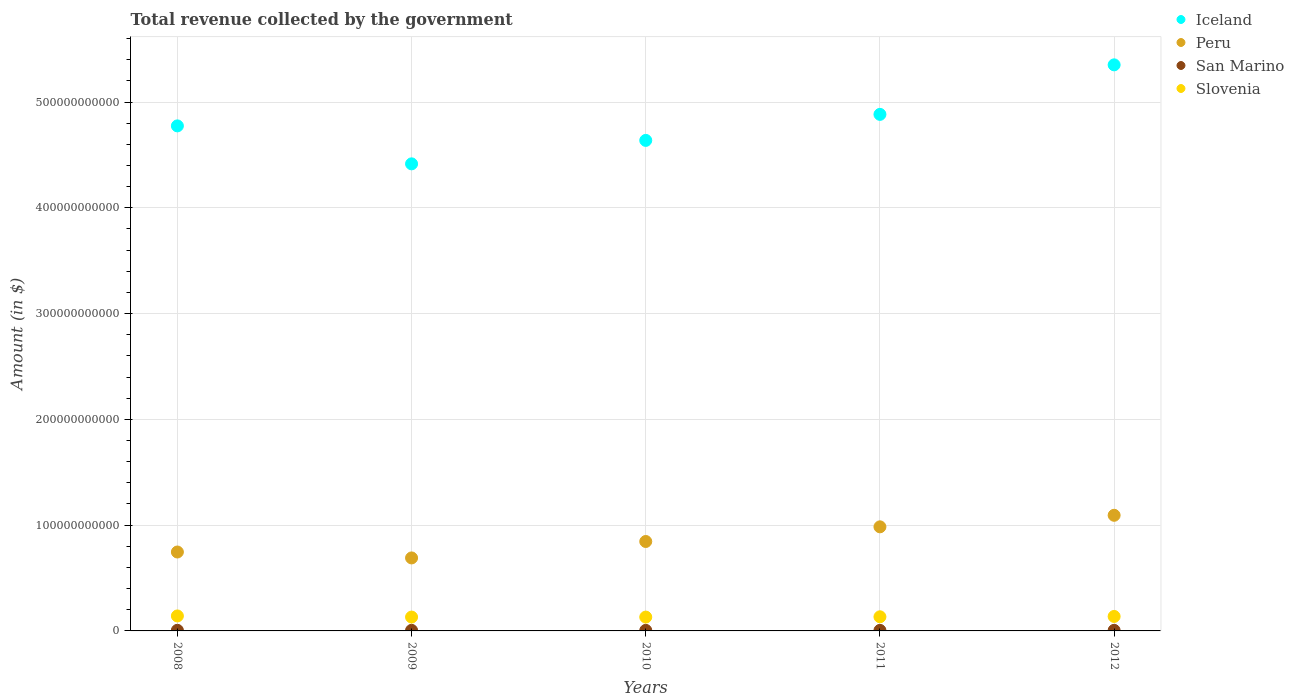How many different coloured dotlines are there?
Your response must be concise. 4. Is the number of dotlines equal to the number of legend labels?
Your answer should be compact. Yes. What is the total revenue collected by the government in San Marino in 2010?
Your answer should be compact. 5.31e+08. Across all years, what is the maximum total revenue collected by the government in Slovenia?
Keep it short and to the point. 1.42e+1. Across all years, what is the minimum total revenue collected by the government in Iceland?
Give a very brief answer. 4.42e+11. In which year was the total revenue collected by the government in Iceland maximum?
Give a very brief answer. 2012. In which year was the total revenue collected by the government in Peru minimum?
Your answer should be compact. 2009. What is the total total revenue collected by the government in Slovenia in the graph?
Give a very brief answer. 6.74e+1. What is the difference between the total revenue collected by the government in Peru in 2009 and that in 2012?
Your answer should be very brief. -4.03e+1. What is the difference between the total revenue collected by the government in Peru in 2011 and the total revenue collected by the government in Slovenia in 2008?
Your answer should be very brief. 8.42e+1. What is the average total revenue collected by the government in Slovenia per year?
Offer a very short reply. 1.35e+1. In the year 2011, what is the difference between the total revenue collected by the government in Slovenia and total revenue collected by the government in Iceland?
Give a very brief answer. -4.75e+11. What is the ratio of the total revenue collected by the government in Iceland in 2008 to that in 2009?
Your response must be concise. 1.08. Is the total revenue collected by the government in Peru in 2009 less than that in 2012?
Your answer should be compact. Yes. What is the difference between the highest and the second highest total revenue collected by the government in Iceland?
Ensure brevity in your answer.  4.68e+1. What is the difference between the highest and the lowest total revenue collected by the government in Iceland?
Keep it short and to the point. 9.36e+1. In how many years, is the total revenue collected by the government in Iceland greater than the average total revenue collected by the government in Iceland taken over all years?
Keep it short and to the point. 2. Is the sum of the total revenue collected by the government in Slovenia in 2009 and 2011 greater than the maximum total revenue collected by the government in Iceland across all years?
Keep it short and to the point. No. Does the total revenue collected by the government in Slovenia monotonically increase over the years?
Offer a terse response. No. Is the total revenue collected by the government in San Marino strictly greater than the total revenue collected by the government in Slovenia over the years?
Your response must be concise. No. How many years are there in the graph?
Your response must be concise. 5. What is the difference between two consecutive major ticks on the Y-axis?
Keep it short and to the point. 1.00e+11. Are the values on the major ticks of Y-axis written in scientific E-notation?
Offer a terse response. No. Does the graph contain any zero values?
Give a very brief answer. No. How many legend labels are there?
Offer a very short reply. 4. What is the title of the graph?
Provide a succinct answer. Total revenue collected by the government. What is the label or title of the Y-axis?
Offer a very short reply. Amount (in $). What is the Amount (in $) in Iceland in 2008?
Your answer should be very brief. 4.77e+11. What is the Amount (in $) in Peru in 2008?
Give a very brief answer. 7.46e+1. What is the Amount (in $) of San Marino in 2008?
Make the answer very short. 5.91e+08. What is the Amount (in $) in Slovenia in 2008?
Offer a very short reply. 1.42e+1. What is the Amount (in $) in Iceland in 2009?
Provide a short and direct response. 4.42e+11. What is the Amount (in $) of Peru in 2009?
Your answer should be very brief. 6.90e+1. What is the Amount (in $) in San Marino in 2009?
Your answer should be very brief. 5.62e+08. What is the Amount (in $) in Slovenia in 2009?
Your response must be concise. 1.31e+1. What is the Amount (in $) of Iceland in 2010?
Keep it short and to the point. 4.64e+11. What is the Amount (in $) in Peru in 2010?
Your answer should be compact. 8.45e+1. What is the Amount (in $) in San Marino in 2010?
Provide a short and direct response. 5.31e+08. What is the Amount (in $) in Slovenia in 2010?
Provide a succinct answer. 1.31e+1. What is the Amount (in $) in Iceland in 2011?
Your answer should be very brief. 4.88e+11. What is the Amount (in $) of Peru in 2011?
Offer a very short reply. 9.84e+1. What is the Amount (in $) in San Marino in 2011?
Your response must be concise. 5.23e+08. What is the Amount (in $) in Slovenia in 2011?
Provide a succinct answer. 1.34e+1. What is the Amount (in $) of Iceland in 2012?
Provide a succinct answer. 5.35e+11. What is the Amount (in $) in Peru in 2012?
Make the answer very short. 1.09e+11. What is the Amount (in $) of San Marino in 2012?
Ensure brevity in your answer.  5.53e+08. What is the Amount (in $) in Slovenia in 2012?
Offer a very short reply. 1.37e+1. Across all years, what is the maximum Amount (in $) of Iceland?
Your answer should be very brief. 5.35e+11. Across all years, what is the maximum Amount (in $) of Peru?
Provide a succinct answer. 1.09e+11. Across all years, what is the maximum Amount (in $) in San Marino?
Provide a succinct answer. 5.91e+08. Across all years, what is the maximum Amount (in $) in Slovenia?
Make the answer very short. 1.42e+1. Across all years, what is the minimum Amount (in $) in Iceland?
Offer a terse response. 4.42e+11. Across all years, what is the minimum Amount (in $) of Peru?
Provide a succinct answer. 6.90e+1. Across all years, what is the minimum Amount (in $) of San Marino?
Make the answer very short. 5.23e+08. Across all years, what is the minimum Amount (in $) in Slovenia?
Provide a succinct answer. 1.31e+1. What is the total Amount (in $) of Iceland in the graph?
Give a very brief answer. 2.41e+12. What is the total Amount (in $) in Peru in the graph?
Your response must be concise. 4.36e+11. What is the total Amount (in $) of San Marino in the graph?
Your answer should be very brief. 2.76e+09. What is the total Amount (in $) in Slovenia in the graph?
Make the answer very short. 6.74e+1. What is the difference between the Amount (in $) of Iceland in 2008 and that in 2009?
Provide a succinct answer. 3.59e+1. What is the difference between the Amount (in $) of Peru in 2008 and that in 2009?
Provide a short and direct response. 5.60e+09. What is the difference between the Amount (in $) in San Marino in 2008 and that in 2009?
Provide a succinct answer. 2.87e+07. What is the difference between the Amount (in $) in Slovenia in 2008 and that in 2009?
Provide a short and direct response. 1.07e+09. What is the difference between the Amount (in $) of Iceland in 2008 and that in 2010?
Your answer should be very brief. 1.37e+1. What is the difference between the Amount (in $) of Peru in 2008 and that in 2010?
Your answer should be very brief. -9.94e+09. What is the difference between the Amount (in $) in San Marino in 2008 and that in 2010?
Your answer should be compact. 6.02e+07. What is the difference between the Amount (in $) of Slovenia in 2008 and that in 2010?
Keep it short and to the point. 1.08e+09. What is the difference between the Amount (in $) in Iceland in 2008 and that in 2011?
Your response must be concise. -1.09e+1. What is the difference between the Amount (in $) of Peru in 2008 and that in 2011?
Your response must be concise. -2.38e+1. What is the difference between the Amount (in $) of San Marino in 2008 and that in 2011?
Give a very brief answer. 6.76e+07. What is the difference between the Amount (in $) of Slovenia in 2008 and that in 2011?
Provide a succinct answer. 8.01e+08. What is the difference between the Amount (in $) of Iceland in 2008 and that in 2012?
Your response must be concise. -5.77e+1. What is the difference between the Amount (in $) in Peru in 2008 and that in 2012?
Your response must be concise. -3.47e+1. What is the difference between the Amount (in $) of San Marino in 2008 and that in 2012?
Your response must be concise. 3.76e+07. What is the difference between the Amount (in $) of Slovenia in 2008 and that in 2012?
Provide a succinct answer. 4.74e+08. What is the difference between the Amount (in $) in Iceland in 2009 and that in 2010?
Make the answer very short. -2.22e+1. What is the difference between the Amount (in $) of Peru in 2009 and that in 2010?
Give a very brief answer. -1.55e+1. What is the difference between the Amount (in $) of San Marino in 2009 and that in 2010?
Give a very brief answer. 3.15e+07. What is the difference between the Amount (in $) in Slovenia in 2009 and that in 2010?
Provide a succinct answer. 1.26e+07. What is the difference between the Amount (in $) of Iceland in 2009 and that in 2011?
Make the answer very short. -4.68e+1. What is the difference between the Amount (in $) of Peru in 2009 and that in 2011?
Your answer should be compact. -2.94e+1. What is the difference between the Amount (in $) of San Marino in 2009 and that in 2011?
Your answer should be compact. 3.89e+07. What is the difference between the Amount (in $) in Slovenia in 2009 and that in 2011?
Provide a succinct answer. -2.66e+08. What is the difference between the Amount (in $) in Iceland in 2009 and that in 2012?
Offer a terse response. -9.36e+1. What is the difference between the Amount (in $) of Peru in 2009 and that in 2012?
Offer a terse response. -4.03e+1. What is the difference between the Amount (in $) of San Marino in 2009 and that in 2012?
Provide a succinct answer. 8.90e+06. What is the difference between the Amount (in $) in Slovenia in 2009 and that in 2012?
Your answer should be very brief. -5.93e+08. What is the difference between the Amount (in $) in Iceland in 2010 and that in 2011?
Offer a terse response. -2.46e+1. What is the difference between the Amount (in $) of Peru in 2010 and that in 2011?
Provide a succinct answer. -1.39e+1. What is the difference between the Amount (in $) in San Marino in 2010 and that in 2011?
Ensure brevity in your answer.  7.36e+06. What is the difference between the Amount (in $) of Slovenia in 2010 and that in 2011?
Offer a terse response. -2.78e+08. What is the difference between the Amount (in $) of Iceland in 2010 and that in 2012?
Ensure brevity in your answer.  -7.14e+1. What is the difference between the Amount (in $) of Peru in 2010 and that in 2012?
Your response must be concise. -2.48e+1. What is the difference between the Amount (in $) in San Marino in 2010 and that in 2012?
Your response must be concise. -2.26e+07. What is the difference between the Amount (in $) in Slovenia in 2010 and that in 2012?
Offer a very short reply. -6.06e+08. What is the difference between the Amount (in $) in Iceland in 2011 and that in 2012?
Keep it short and to the point. -4.68e+1. What is the difference between the Amount (in $) of Peru in 2011 and that in 2012?
Your answer should be compact. -1.09e+1. What is the difference between the Amount (in $) in San Marino in 2011 and that in 2012?
Your response must be concise. -3.00e+07. What is the difference between the Amount (in $) of Slovenia in 2011 and that in 2012?
Your answer should be compact. -3.27e+08. What is the difference between the Amount (in $) of Iceland in 2008 and the Amount (in $) of Peru in 2009?
Your answer should be compact. 4.08e+11. What is the difference between the Amount (in $) in Iceland in 2008 and the Amount (in $) in San Marino in 2009?
Give a very brief answer. 4.77e+11. What is the difference between the Amount (in $) in Iceland in 2008 and the Amount (in $) in Slovenia in 2009?
Provide a succinct answer. 4.64e+11. What is the difference between the Amount (in $) of Peru in 2008 and the Amount (in $) of San Marino in 2009?
Your answer should be compact. 7.40e+1. What is the difference between the Amount (in $) in Peru in 2008 and the Amount (in $) in Slovenia in 2009?
Offer a very short reply. 6.15e+1. What is the difference between the Amount (in $) of San Marino in 2008 and the Amount (in $) of Slovenia in 2009?
Give a very brief answer. -1.25e+1. What is the difference between the Amount (in $) of Iceland in 2008 and the Amount (in $) of Peru in 2010?
Give a very brief answer. 3.93e+11. What is the difference between the Amount (in $) of Iceland in 2008 and the Amount (in $) of San Marino in 2010?
Give a very brief answer. 4.77e+11. What is the difference between the Amount (in $) of Iceland in 2008 and the Amount (in $) of Slovenia in 2010?
Ensure brevity in your answer.  4.64e+11. What is the difference between the Amount (in $) in Peru in 2008 and the Amount (in $) in San Marino in 2010?
Provide a succinct answer. 7.41e+1. What is the difference between the Amount (in $) in Peru in 2008 and the Amount (in $) in Slovenia in 2010?
Give a very brief answer. 6.15e+1. What is the difference between the Amount (in $) of San Marino in 2008 and the Amount (in $) of Slovenia in 2010?
Offer a terse response. -1.25e+1. What is the difference between the Amount (in $) of Iceland in 2008 and the Amount (in $) of Peru in 2011?
Keep it short and to the point. 3.79e+11. What is the difference between the Amount (in $) in Iceland in 2008 and the Amount (in $) in San Marino in 2011?
Ensure brevity in your answer.  4.77e+11. What is the difference between the Amount (in $) in Iceland in 2008 and the Amount (in $) in Slovenia in 2011?
Give a very brief answer. 4.64e+11. What is the difference between the Amount (in $) in Peru in 2008 and the Amount (in $) in San Marino in 2011?
Offer a terse response. 7.41e+1. What is the difference between the Amount (in $) of Peru in 2008 and the Amount (in $) of Slovenia in 2011?
Your answer should be compact. 6.12e+1. What is the difference between the Amount (in $) in San Marino in 2008 and the Amount (in $) in Slovenia in 2011?
Your answer should be compact. -1.28e+1. What is the difference between the Amount (in $) of Iceland in 2008 and the Amount (in $) of Peru in 2012?
Keep it short and to the point. 3.68e+11. What is the difference between the Amount (in $) of Iceland in 2008 and the Amount (in $) of San Marino in 2012?
Your response must be concise. 4.77e+11. What is the difference between the Amount (in $) in Iceland in 2008 and the Amount (in $) in Slovenia in 2012?
Make the answer very short. 4.64e+11. What is the difference between the Amount (in $) of Peru in 2008 and the Amount (in $) of San Marino in 2012?
Your response must be concise. 7.41e+1. What is the difference between the Amount (in $) of Peru in 2008 and the Amount (in $) of Slovenia in 2012?
Provide a succinct answer. 6.09e+1. What is the difference between the Amount (in $) in San Marino in 2008 and the Amount (in $) in Slovenia in 2012?
Ensure brevity in your answer.  -1.31e+1. What is the difference between the Amount (in $) in Iceland in 2009 and the Amount (in $) in Peru in 2010?
Provide a short and direct response. 3.57e+11. What is the difference between the Amount (in $) of Iceland in 2009 and the Amount (in $) of San Marino in 2010?
Give a very brief answer. 4.41e+11. What is the difference between the Amount (in $) of Iceland in 2009 and the Amount (in $) of Slovenia in 2010?
Provide a short and direct response. 4.28e+11. What is the difference between the Amount (in $) in Peru in 2009 and the Amount (in $) in San Marino in 2010?
Provide a short and direct response. 6.85e+1. What is the difference between the Amount (in $) in Peru in 2009 and the Amount (in $) in Slovenia in 2010?
Make the answer very short. 5.59e+1. What is the difference between the Amount (in $) in San Marino in 2009 and the Amount (in $) in Slovenia in 2010?
Your response must be concise. -1.25e+1. What is the difference between the Amount (in $) of Iceland in 2009 and the Amount (in $) of Peru in 2011?
Make the answer very short. 3.43e+11. What is the difference between the Amount (in $) of Iceland in 2009 and the Amount (in $) of San Marino in 2011?
Your answer should be very brief. 4.41e+11. What is the difference between the Amount (in $) in Iceland in 2009 and the Amount (in $) in Slovenia in 2011?
Ensure brevity in your answer.  4.28e+11. What is the difference between the Amount (in $) in Peru in 2009 and the Amount (in $) in San Marino in 2011?
Your answer should be compact. 6.85e+1. What is the difference between the Amount (in $) of Peru in 2009 and the Amount (in $) of Slovenia in 2011?
Provide a short and direct response. 5.57e+1. What is the difference between the Amount (in $) of San Marino in 2009 and the Amount (in $) of Slovenia in 2011?
Your answer should be very brief. -1.28e+1. What is the difference between the Amount (in $) of Iceland in 2009 and the Amount (in $) of Peru in 2012?
Your response must be concise. 3.32e+11. What is the difference between the Amount (in $) of Iceland in 2009 and the Amount (in $) of San Marino in 2012?
Give a very brief answer. 4.41e+11. What is the difference between the Amount (in $) of Iceland in 2009 and the Amount (in $) of Slovenia in 2012?
Provide a succinct answer. 4.28e+11. What is the difference between the Amount (in $) of Peru in 2009 and the Amount (in $) of San Marino in 2012?
Your answer should be very brief. 6.85e+1. What is the difference between the Amount (in $) in Peru in 2009 and the Amount (in $) in Slovenia in 2012?
Make the answer very short. 5.53e+1. What is the difference between the Amount (in $) of San Marino in 2009 and the Amount (in $) of Slovenia in 2012?
Your answer should be compact. -1.31e+1. What is the difference between the Amount (in $) in Iceland in 2010 and the Amount (in $) in Peru in 2011?
Keep it short and to the point. 3.65e+11. What is the difference between the Amount (in $) in Iceland in 2010 and the Amount (in $) in San Marino in 2011?
Ensure brevity in your answer.  4.63e+11. What is the difference between the Amount (in $) of Iceland in 2010 and the Amount (in $) of Slovenia in 2011?
Offer a very short reply. 4.50e+11. What is the difference between the Amount (in $) in Peru in 2010 and the Amount (in $) in San Marino in 2011?
Keep it short and to the point. 8.40e+1. What is the difference between the Amount (in $) in Peru in 2010 and the Amount (in $) in Slovenia in 2011?
Ensure brevity in your answer.  7.12e+1. What is the difference between the Amount (in $) of San Marino in 2010 and the Amount (in $) of Slovenia in 2011?
Offer a very short reply. -1.28e+1. What is the difference between the Amount (in $) of Iceland in 2010 and the Amount (in $) of Peru in 2012?
Provide a short and direct response. 3.54e+11. What is the difference between the Amount (in $) of Iceland in 2010 and the Amount (in $) of San Marino in 2012?
Offer a terse response. 4.63e+11. What is the difference between the Amount (in $) in Iceland in 2010 and the Amount (in $) in Slovenia in 2012?
Provide a succinct answer. 4.50e+11. What is the difference between the Amount (in $) of Peru in 2010 and the Amount (in $) of San Marino in 2012?
Offer a very short reply. 8.40e+1. What is the difference between the Amount (in $) of Peru in 2010 and the Amount (in $) of Slovenia in 2012?
Offer a very short reply. 7.09e+1. What is the difference between the Amount (in $) of San Marino in 2010 and the Amount (in $) of Slovenia in 2012?
Keep it short and to the point. -1.32e+1. What is the difference between the Amount (in $) in Iceland in 2011 and the Amount (in $) in Peru in 2012?
Ensure brevity in your answer.  3.79e+11. What is the difference between the Amount (in $) in Iceland in 2011 and the Amount (in $) in San Marino in 2012?
Your answer should be compact. 4.88e+11. What is the difference between the Amount (in $) in Iceland in 2011 and the Amount (in $) in Slovenia in 2012?
Keep it short and to the point. 4.75e+11. What is the difference between the Amount (in $) in Peru in 2011 and the Amount (in $) in San Marino in 2012?
Make the answer very short. 9.79e+1. What is the difference between the Amount (in $) in Peru in 2011 and the Amount (in $) in Slovenia in 2012?
Give a very brief answer. 8.47e+1. What is the difference between the Amount (in $) in San Marino in 2011 and the Amount (in $) in Slovenia in 2012?
Provide a succinct answer. -1.32e+1. What is the average Amount (in $) in Iceland per year?
Offer a very short reply. 4.81e+11. What is the average Amount (in $) in Peru per year?
Offer a terse response. 8.72e+1. What is the average Amount (in $) in San Marino per year?
Provide a short and direct response. 5.52e+08. What is the average Amount (in $) in Slovenia per year?
Provide a short and direct response. 1.35e+1. In the year 2008, what is the difference between the Amount (in $) in Iceland and Amount (in $) in Peru?
Your response must be concise. 4.03e+11. In the year 2008, what is the difference between the Amount (in $) in Iceland and Amount (in $) in San Marino?
Your response must be concise. 4.77e+11. In the year 2008, what is the difference between the Amount (in $) in Iceland and Amount (in $) in Slovenia?
Your answer should be very brief. 4.63e+11. In the year 2008, what is the difference between the Amount (in $) of Peru and Amount (in $) of San Marino?
Give a very brief answer. 7.40e+1. In the year 2008, what is the difference between the Amount (in $) in Peru and Amount (in $) in Slovenia?
Give a very brief answer. 6.04e+1. In the year 2008, what is the difference between the Amount (in $) in San Marino and Amount (in $) in Slovenia?
Make the answer very short. -1.36e+1. In the year 2009, what is the difference between the Amount (in $) of Iceland and Amount (in $) of Peru?
Offer a terse response. 3.73e+11. In the year 2009, what is the difference between the Amount (in $) in Iceland and Amount (in $) in San Marino?
Make the answer very short. 4.41e+11. In the year 2009, what is the difference between the Amount (in $) of Iceland and Amount (in $) of Slovenia?
Offer a very short reply. 4.28e+11. In the year 2009, what is the difference between the Amount (in $) in Peru and Amount (in $) in San Marino?
Provide a short and direct response. 6.84e+1. In the year 2009, what is the difference between the Amount (in $) of Peru and Amount (in $) of Slovenia?
Provide a short and direct response. 5.59e+1. In the year 2009, what is the difference between the Amount (in $) in San Marino and Amount (in $) in Slovenia?
Offer a terse response. -1.25e+1. In the year 2010, what is the difference between the Amount (in $) in Iceland and Amount (in $) in Peru?
Keep it short and to the point. 3.79e+11. In the year 2010, what is the difference between the Amount (in $) in Iceland and Amount (in $) in San Marino?
Your response must be concise. 4.63e+11. In the year 2010, what is the difference between the Amount (in $) of Iceland and Amount (in $) of Slovenia?
Provide a succinct answer. 4.51e+11. In the year 2010, what is the difference between the Amount (in $) in Peru and Amount (in $) in San Marino?
Offer a terse response. 8.40e+1. In the year 2010, what is the difference between the Amount (in $) of Peru and Amount (in $) of Slovenia?
Your answer should be compact. 7.15e+1. In the year 2010, what is the difference between the Amount (in $) of San Marino and Amount (in $) of Slovenia?
Provide a short and direct response. -1.25e+1. In the year 2011, what is the difference between the Amount (in $) in Iceland and Amount (in $) in Peru?
Keep it short and to the point. 3.90e+11. In the year 2011, what is the difference between the Amount (in $) of Iceland and Amount (in $) of San Marino?
Offer a very short reply. 4.88e+11. In the year 2011, what is the difference between the Amount (in $) in Iceland and Amount (in $) in Slovenia?
Your answer should be very brief. 4.75e+11. In the year 2011, what is the difference between the Amount (in $) of Peru and Amount (in $) of San Marino?
Offer a terse response. 9.79e+1. In the year 2011, what is the difference between the Amount (in $) of Peru and Amount (in $) of Slovenia?
Offer a very short reply. 8.50e+1. In the year 2011, what is the difference between the Amount (in $) in San Marino and Amount (in $) in Slovenia?
Keep it short and to the point. -1.28e+1. In the year 2012, what is the difference between the Amount (in $) in Iceland and Amount (in $) in Peru?
Provide a succinct answer. 4.26e+11. In the year 2012, what is the difference between the Amount (in $) in Iceland and Amount (in $) in San Marino?
Keep it short and to the point. 5.35e+11. In the year 2012, what is the difference between the Amount (in $) of Iceland and Amount (in $) of Slovenia?
Your answer should be compact. 5.21e+11. In the year 2012, what is the difference between the Amount (in $) of Peru and Amount (in $) of San Marino?
Your answer should be compact. 1.09e+11. In the year 2012, what is the difference between the Amount (in $) of Peru and Amount (in $) of Slovenia?
Your answer should be very brief. 9.56e+1. In the year 2012, what is the difference between the Amount (in $) in San Marino and Amount (in $) in Slovenia?
Offer a terse response. -1.31e+1. What is the ratio of the Amount (in $) of Iceland in 2008 to that in 2009?
Make the answer very short. 1.08. What is the ratio of the Amount (in $) of Peru in 2008 to that in 2009?
Your answer should be compact. 1.08. What is the ratio of the Amount (in $) in San Marino in 2008 to that in 2009?
Your answer should be compact. 1.05. What is the ratio of the Amount (in $) in Slovenia in 2008 to that in 2009?
Provide a succinct answer. 1.08. What is the ratio of the Amount (in $) in Iceland in 2008 to that in 2010?
Your response must be concise. 1.03. What is the ratio of the Amount (in $) of Peru in 2008 to that in 2010?
Your answer should be compact. 0.88. What is the ratio of the Amount (in $) of San Marino in 2008 to that in 2010?
Your response must be concise. 1.11. What is the ratio of the Amount (in $) in Slovenia in 2008 to that in 2010?
Your response must be concise. 1.08. What is the ratio of the Amount (in $) of Iceland in 2008 to that in 2011?
Your answer should be compact. 0.98. What is the ratio of the Amount (in $) in Peru in 2008 to that in 2011?
Make the answer very short. 0.76. What is the ratio of the Amount (in $) in San Marino in 2008 to that in 2011?
Your answer should be compact. 1.13. What is the ratio of the Amount (in $) in Slovenia in 2008 to that in 2011?
Offer a very short reply. 1.06. What is the ratio of the Amount (in $) in Iceland in 2008 to that in 2012?
Ensure brevity in your answer.  0.89. What is the ratio of the Amount (in $) in Peru in 2008 to that in 2012?
Keep it short and to the point. 0.68. What is the ratio of the Amount (in $) of San Marino in 2008 to that in 2012?
Ensure brevity in your answer.  1.07. What is the ratio of the Amount (in $) of Slovenia in 2008 to that in 2012?
Provide a short and direct response. 1.03. What is the ratio of the Amount (in $) in Iceland in 2009 to that in 2010?
Your answer should be very brief. 0.95. What is the ratio of the Amount (in $) of Peru in 2009 to that in 2010?
Offer a terse response. 0.82. What is the ratio of the Amount (in $) of San Marino in 2009 to that in 2010?
Offer a very short reply. 1.06. What is the ratio of the Amount (in $) in Iceland in 2009 to that in 2011?
Give a very brief answer. 0.9. What is the ratio of the Amount (in $) of Peru in 2009 to that in 2011?
Keep it short and to the point. 0.7. What is the ratio of the Amount (in $) in San Marino in 2009 to that in 2011?
Your answer should be compact. 1.07. What is the ratio of the Amount (in $) of Slovenia in 2009 to that in 2011?
Your response must be concise. 0.98. What is the ratio of the Amount (in $) in Iceland in 2009 to that in 2012?
Your response must be concise. 0.83. What is the ratio of the Amount (in $) of Peru in 2009 to that in 2012?
Provide a succinct answer. 0.63. What is the ratio of the Amount (in $) of San Marino in 2009 to that in 2012?
Make the answer very short. 1.02. What is the ratio of the Amount (in $) of Slovenia in 2009 to that in 2012?
Provide a short and direct response. 0.96. What is the ratio of the Amount (in $) in Iceland in 2010 to that in 2011?
Offer a terse response. 0.95. What is the ratio of the Amount (in $) of Peru in 2010 to that in 2011?
Give a very brief answer. 0.86. What is the ratio of the Amount (in $) of San Marino in 2010 to that in 2011?
Make the answer very short. 1.01. What is the ratio of the Amount (in $) in Slovenia in 2010 to that in 2011?
Your response must be concise. 0.98. What is the ratio of the Amount (in $) in Iceland in 2010 to that in 2012?
Ensure brevity in your answer.  0.87. What is the ratio of the Amount (in $) of Peru in 2010 to that in 2012?
Ensure brevity in your answer.  0.77. What is the ratio of the Amount (in $) in San Marino in 2010 to that in 2012?
Keep it short and to the point. 0.96. What is the ratio of the Amount (in $) of Slovenia in 2010 to that in 2012?
Provide a short and direct response. 0.96. What is the ratio of the Amount (in $) in Iceland in 2011 to that in 2012?
Your answer should be very brief. 0.91. What is the ratio of the Amount (in $) in Peru in 2011 to that in 2012?
Ensure brevity in your answer.  0.9. What is the ratio of the Amount (in $) of San Marino in 2011 to that in 2012?
Make the answer very short. 0.95. What is the ratio of the Amount (in $) of Slovenia in 2011 to that in 2012?
Offer a terse response. 0.98. What is the difference between the highest and the second highest Amount (in $) in Iceland?
Provide a short and direct response. 4.68e+1. What is the difference between the highest and the second highest Amount (in $) of Peru?
Your answer should be compact. 1.09e+1. What is the difference between the highest and the second highest Amount (in $) in San Marino?
Provide a succinct answer. 2.87e+07. What is the difference between the highest and the second highest Amount (in $) of Slovenia?
Make the answer very short. 4.74e+08. What is the difference between the highest and the lowest Amount (in $) of Iceland?
Give a very brief answer. 9.36e+1. What is the difference between the highest and the lowest Amount (in $) in Peru?
Make the answer very short. 4.03e+1. What is the difference between the highest and the lowest Amount (in $) of San Marino?
Ensure brevity in your answer.  6.76e+07. What is the difference between the highest and the lowest Amount (in $) in Slovenia?
Provide a succinct answer. 1.08e+09. 